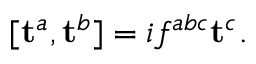Convert formula to latex. <formula><loc_0><loc_0><loc_500><loc_500>[ t ^ { a } , t ^ { b } ] = i f ^ { a b c } t ^ { c } .</formula> 